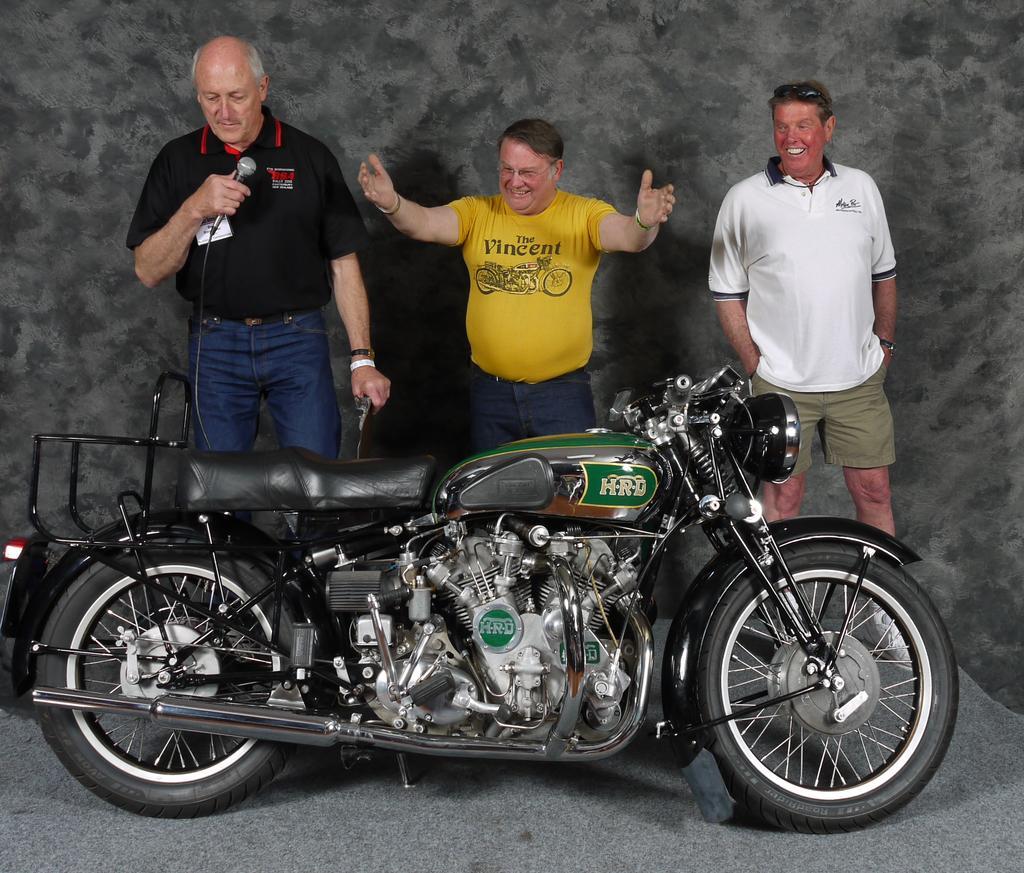Could you give a brief overview of what you see in this image? In this image we can see people and vehicle. On the left hand side we can see a person holding an object in his hand. 